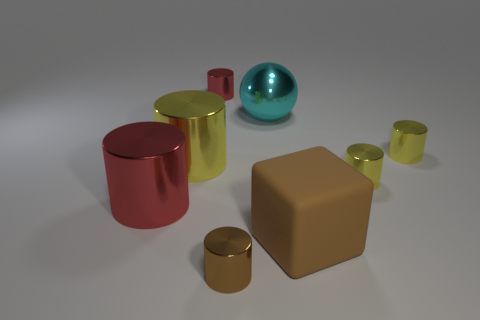Are there any other things that are the same material as the big cube?
Keep it short and to the point. No. How many gray cubes are there?
Your response must be concise. 0. Are there fewer large things behind the rubber thing than shiny things that are in front of the small red shiny thing?
Offer a very short reply. Yes. Is the number of red things that are in front of the large red cylinder less than the number of blocks?
Provide a short and direct response. Yes. There is a yellow cylinder behind the yellow object to the left of the red metal cylinder behind the cyan object; what is its material?
Provide a short and direct response. Metal. What number of objects are red objects that are behind the big brown rubber cube or brown things that are in front of the large cube?
Provide a succinct answer. 3. What number of matte objects are tiny red things or cylinders?
Give a very brief answer. 0. What shape is the brown thing that is made of the same material as the big sphere?
Your answer should be very brief. Cylinder. What number of large brown things have the same shape as the big red object?
Give a very brief answer. 0. Does the yellow metallic thing that is on the left side of the brown matte cube have the same shape as the big shiny thing that is to the right of the big yellow shiny object?
Provide a succinct answer. No. 